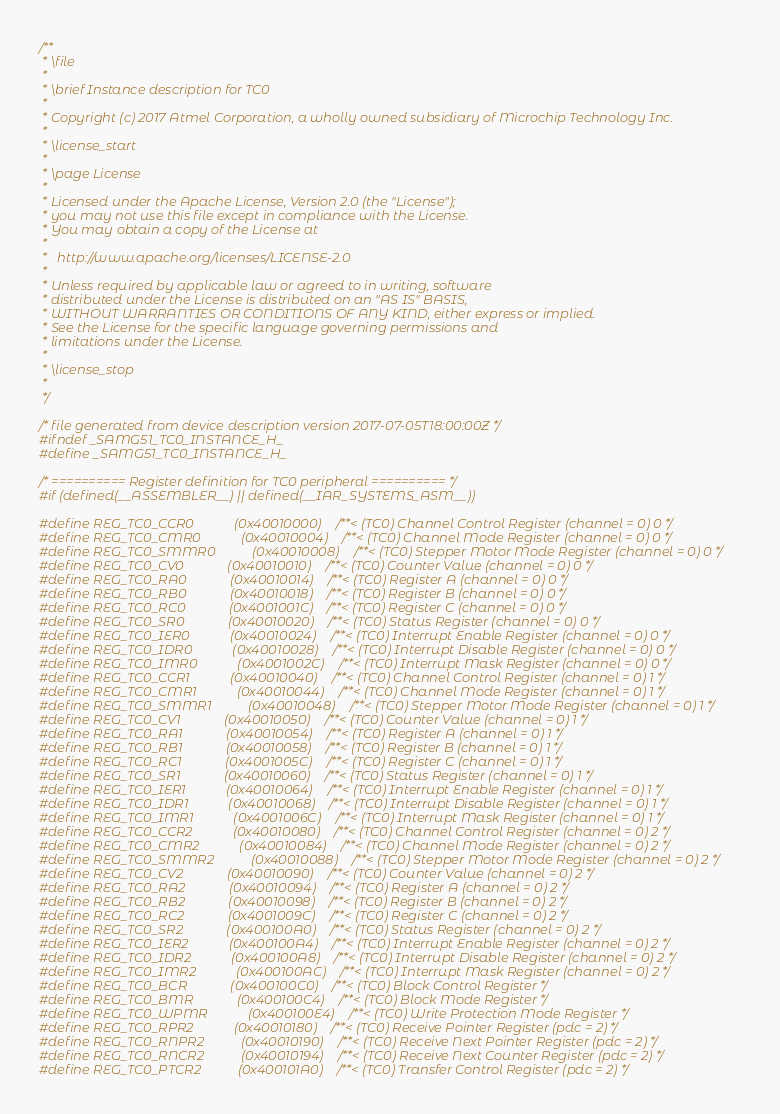Convert code to text. <code><loc_0><loc_0><loc_500><loc_500><_C_>/**
 * \file
 *
 * \brief Instance description for TC0
 *
 * Copyright (c) 2017 Atmel Corporation, a wholly owned subsidiary of Microchip Technology Inc.
 *
 * \license_start
 *
 * \page License
 *
 * Licensed under the Apache License, Version 2.0 (the "License");
 * you may not use this file except in compliance with the License.
 * You may obtain a copy of the License at
 *
 *   http://www.apache.org/licenses/LICENSE-2.0
 *
 * Unless required by applicable law or agreed to in writing, software
 * distributed under the License is distributed on an "AS IS" BASIS,
 * WITHOUT WARRANTIES OR CONDITIONS OF ANY KIND, either express or implied.
 * See the License for the specific language governing permissions and
 * limitations under the License.
 *
 * \license_stop
 *
 */

/* file generated from device description version 2017-07-05T18:00:00Z */
#ifndef _SAMG51_TC0_INSTANCE_H_
#define _SAMG51_TC0_INSTANCE_H_

/* ========== Register definition for TC0 peripheral ========== */
#if (defined(__ASSEMBLER__) || defined(__IAR_SYSTEMS_ASM__))

#define REG_TC0_CCR0            (0x40010000) /**< (TC0) Channel Control Register (channel = 0) 0 */
#define REG_TC0_CMR0            (0x40010004) /**< (TC0) Channel Mode Register (channel = 0) 0 */
#define REG_TC0_SMMR0           (0x40010008) /**< (TC0) Stepper Motor Mode Register (channel = 0) 0 */
#define REG_TC0_CV0             (0x40010010) /**< (TC0) Counter Value (channel = 0) 0 */
#define REG_TC0_RA0             (0x40010014) /**< (TC0) Register A (channel = 0) 0 */
#define REG_TC0_RB0             (0x40010018) /**< (TC0) Register B (channel = 0) 0 */
#define REG_TC0_RC0             (0x4001001C) /**< (TC0) Register C (channel = 0) 0 */
#define REG_TC0_SR0             (0x40010020) /**< (TC0) Status Register (channel = 0) 0 */
#define REG_TC0_IER0            (0x40010024) /**< (TC0) Interrupt Enable Register (channel = 0) 0 */
#define REG_TC0_IDR0            (0x40010028) /**< (TC0) Interrupt Disable Register (channel = 0) 0 */
#define REG_TC0_IMR0            (0x4001002C) /**< (TC0) Interrupt Mask Register (channel = 0) 0 */
#define REG_TC0_CCR1            (0x40010040) /**< (TC0) Channel Control Register (channel = 0) 1 */
#define REG_TC0_CMR1            (0x40010044) /**< (TC0) Channel Mode Register (channel = 0) 1 */
#define REG_TC0_SMMR1           (0x40010048) /**< (TC0) Stepper Motor Mode Register (channel = 0) 1 */
#define REG_TC0_CV1             (0x40010050) /**< (TC0) Counter Value (channel = 0) 1 */
#define REG_TC0_RA1             (0x40010054) /**< (TC0) Register A (channel = 0) 1 */
#define REG_TC0_RB1             (0x40010058) /**< (TC0) Register B (channel = 0) 1 */
#define REG_TC0_RC1             (0x4001005C) /**< (TC0) Register C (channel = 0) 1 */
#define REG_TC0_SR1             (0x40010060) /**< (TC0) Status Register (channel = 0) 1 */
#define REG_TC0_IER1            (0x40010064) /**< (TC0) Interrupt Enable Register (channel = 0) 1 */
#define REG_TC0_IDR1            (0x40010068) /**< (TC0) Interrupt Disable Register (channel = 0) 1 */
#define REG_TC0_IMR1            (0x4001006C) /**< (TC0) Interrupt Mask Register (channel = 0) 1 */
#define REG_TC0_CCR2            (0x40010080) /**< (TC0) Channel Control Register (channel = 0) 2 */
#define REG_TC0_CMR2            (0x40010084) /**< (TC0) Channel Mode Register (channel = 0) 2 */
#define REG_TC0_SMMR2           (0x40010088) /**< (TC0) Stepper Motor Mode Register (channel = 0) 2 */
#define REG_TC0_CV2             (0x40010090) /**< (TC0) Counter Value (channel = 0) 2 */
#define REG_TC0_RA2             (0x40010094) /**< (TC0) Register A (channel = 0) 2 */
#define REG_TC0_RB2             (0x40010098) /**< (TC0) Register B (channel = 0) 2 */
#define REG_TC0_RC2             (0x4001009C) /**< (TC0) Register C (channel = 0) 2 */
#define REG_TC0_SR2             (0x400100A0) /**< (TC0) Status Register (channel = 0) 2 */
#define REG_TC0_IER2            (0x400100A4) /**< (TC0) Interrupt Enable Register (channel = 0) 2 */
#define REG_TC0_IDR2            (0x400100A8) /**< (TC0) Interrupt Disable Register (channel = 0) 2 */
#define REG_TC0_IMR2            (0x400100AC) /**< (TC0) Interrupt Mask Register (channel = 0) 2 */
#define REG_TC0_BCR             (0x400100C0) /**< (TC0) Block Control Register */
#define REG_TC0_BMR             (0x400100C4) /**< (TC0) Block Mode Register */
#define REG_TC0_WPMR            (0x400100E4) /**< (TC0) Write Protection Mode Register */
#define REG_TC0_RPR2            (0x40010180) /**< (TC0) Receive Pointer Register (pdc = 2) */
#define REG_TC0_RNPR2           (0x40010190) /**< (TC0) Receive Next Pointer Register (pdc = 2) */
#define REG_TC0_RNCR2           (0x40010194) /**< (TC0) Receive Next Counter Register (pdc = 2) */
#define REG_TC0_PTCR2           (0x400101A0) /**< (TC0) Transfer Control Register (pdc = 2) */</code> 